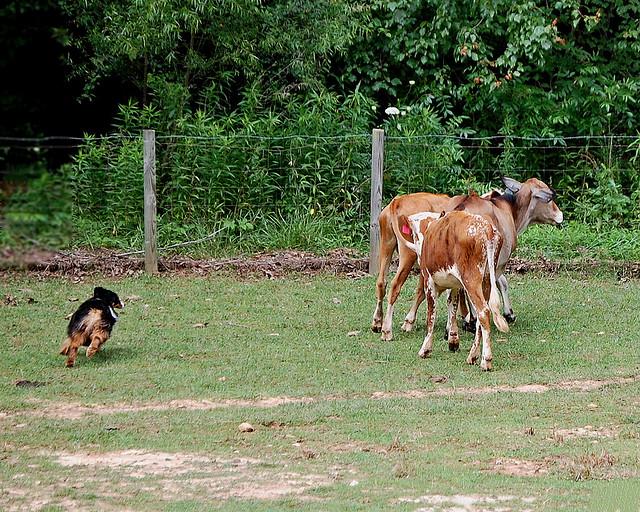Is there any cows in this picture?
Keep it brief. Yes. What is the dog doing?
Give a very brief answer. Herding. Does the vegetation need water?
Be succinct. No. Does the fence appear to be painted?
Quick response, please. No. 